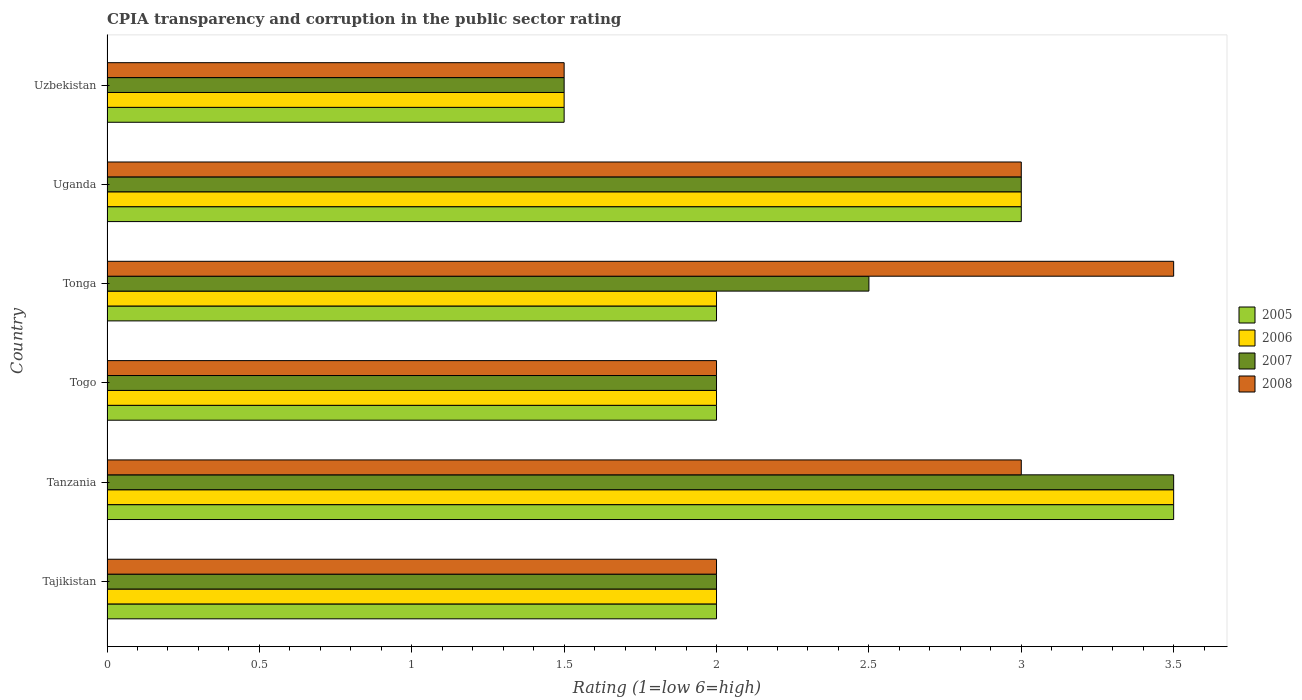How many groups of bars are there?
Make the answer very short. 6. Are the number of bars on each tick of the Y-axis equal?
Give a very brief answer. Yes. What is the label of the 5th group of bars from the top?
Make the answer very short. Tanzania. In how many cases, is the number of bars for a given country not equal to the number of legend labels?
Offer a terse response. 0. What is the CPIA rating in 2007 in Uzbekistan?
Give a very brief answer. 1.5. Across all countries, what is the minimum CPIA rating in 2006?
Provide a short and direct response. 1.5. In which country was the CPIA rating in 2008 maximum?
Offer a terse response. Tonga. In which country was the CPIA rating in 2005 minimum?
Provide a succinct answer. Uzbekistan. What is the average CPIA rating in 2006 per country?
Your answer should be very brief. 2.33. In how many countries, is the CPIA rating in 2005 greater than 0.8 ?
Offer a terse response. 6. What is the ratio of the CPIA rating in 2006 in Tanzania to that in Uzbekistan?
Make the answer very short. 2.33. Is the difference between the CPIA rating in 2006 in Tanzania and Uzbekistan greater than the difference between the CPIA rating in 2008 in Tanzania and Uzbekistan?
Your answer should be very brief. Yes. What is the difference between the highest and the second highest CPIA rating in 2007?
Your response must be concise. 0.5. In how many countries, is the CPIA rating in 2007 greater than the average CPIA rating in 2007 taken over all countries?
Ensure brevity in your answer.  3. Is the sum of the CPIA rating in 2008 in Tajikistan and Tanzania greater than the maximum CPIA rating in 2007 across all countries?
Offer a terse response. Yes. Is it the case that in every country, the sum of the CPIA rating in 2006 and CPIA rating in 2007 is greater than the sum of CPIA rating in 2008 and CPIA rating in 2005?
Provide a succinct answer. No. What does the 1st bar from the bottom in Tanzania represents?
Offer a very short reply. 2005. Are all the bars in the graph horizontal?
Offer a very short reply. Yes. What is the difference between two consecutive major ticks on the X-axis?
Your answer should be compact. 0.5. Are the values on the major ticks of X-axis written in scientific E-notation?
Provide a short and direct response. No. How many legend labels are there?
Keep it short and to the point. 4. How are the legend labels stacked?
Your answer should be very brief. Vertical. What is the title of the graph?
Provide a succinct answer. CPIA transparency and corruption in the public sector rating. Does "1989" appear as one of the legend labels in the graph?
Keep it short and to the point. No. What is the label or title of the X-axis?
Ensure brevity in your answer.  Rating (1=low 6=high). What is the Rating (1=low 6=high) of 2005 in Tajikistan?
Offer a very short reply. 2. What is the Rating (1=low 6=high) of 2005 in Tanzania?
Your response must be concise. 3.5. What is the Rating (1=low 6=high) in 2006 in Tanzania?
Your answer should be very brief. 3.5. What is the Rating (1=low 6=high) in 2007 in Tanzania?
Make the answer very short. 3.5. What is the Rating (1=low 6=high) in 2008 in Tanzania?
Make the answer very short. 3. What is the Rating (1=low 6=high) of 2005 in Togo?
Offer a very short reply. 2. What is the Rating (1=low 6=high) of 2007 in Togo?
Give a very brief answer. 2. What is the Rating (1=low 6=high) of 2005 in Tonga?
Offer a very short reply. 2. What is the Rating (1=low 6=high) of 2007 in Tonga?
Make the answer very short. 2.5. What is the Rating (1=low 6=high) in 2007 in Uzbekistan?
Give a very brief answer. 1.5. What is the Rating (1=low 6=high) of 2008 in Uzbekistan?
Ensure brevity in your answer.  1.5. Across all countries, what is the maximum Rating (1=low 6=high) in 2006?
Your answer should be very brief. 3.5. Across all countries, what is the maximum Rating (1=low 6=high) of 2007?
Your response must be concise. 3.5. Across all countries, what is the maximum Rating (1=low 6=high) in 2008?
Keep it short and to the point. 3.5. What is the total Rating (1=low 6=high) in 2006 in the graph?
Provide a short and direct response. 14. What is the total Rating (1=low 6=high) of 2007 in the graph?
Provide a succinct answer. 14.5. What is the difference between the Rating (1=low 6=high) of 2005 in Tajikistan and that in Tanzania?
Ensure brevity in your answer.  -1.5. What is the difference between the Rating (1=low 6=high) of 2007 in Tajikistan and that in Tanzania?
Make the answer very short. -1.5. What is the difference between the Rating (1=low 6=high) of 2005 in Tajikistan and that in Togo?
Provide a succinct answer. 0. What is the difference between the Rating (1=low 6=high) of 2006 in Tajikistan and that in Togo?
Offer a terse response. 0. What is the difference between the Rating (1=low 6=high) of 2005 in Tajikistan and that in Tonga?
Your answer should be very brief. 0. What is the difference between the Rating (1=low 6=high) of 2007 in Tajikistan and that in Tonga?
Offer a terse response. -0.5. What is the difference between the Rating (1=low 6=high) of 2008 in Tajikistan and that in Tonga?
Provide a short and direct response. -1.5. What is the difference between the Rating (1=low 6=high) in 2006 in Tajikistan and that in Uganda?
Your answer should be very brief. -1. What is the difference between the Rating (1=low 6=high) in 2005 in Tajikistan and that in Uzbekistan?
Provide a short and direct response. 0.5. What is the difference between the Rating (1=low 6=high) in 2006 in Tajikistan and that in Uzbekistan?
Ensure brevity in your answer.  0.5. What is the difference between the Rating (1=low 6=high) in 2005 in Tanzania and that in Togo?
Offer a terse response. 1.5. What is the difference between the Rating (1=low 6=high) of 2006 in Tanzania and that in Togo?
Your response must be concise. 1.5. What is the difference between the Rating (1=low 6=high) of 2007 in Tanzania and that in Togo?
Offer a very short reply. 1.5. What is the difference between the Rating (1=low 6=high) in 2005 in Tanzania and that in Tonga?
Give a very brief answer. 1.5. What is the difference between the Rating (1=low 6=high) in 2006 in Tanzania and that in Tonga?
Offer a terse response. 1.5. What is the difference between the Rating (1=low 6=high) of 2006 in Tanzania and that in Uganda?
Keep it short and to the point. 0.5. What is the difference between the Rating (1=low 6=high) in 2008 in Tanzania and that in Uganda?
Provide a succinct answer. 0. What is the difference between the Rating (1=low 6=high) in 2005 in Tanzania and that in Uzbekistan?
Provide a succinct answer. 2. What is the difference between the Rating (1=low 6=high) in 2008 in Tanzania and that in Uzbekistan?
Offer a very short reply. 1.5. What is the difference between the Rating (1=low 6=high) in 2006 in Togo and that in Tonga?
Provide a succinct answer. 0. What is the difference between the Rating (1=low 6=high) of 2007 in Togo and that in Tonga?
Your answer should be compact. -0.5. What is the difference between the Rating (1=low 6=high) in 2008 in Togo and that in Tonga?
Provide a succinct answer. -1.5. What is the difference between the Rating (1=low 6=high) of 2005 in Togo and that in Uganda?
Provide a succinct answer. -1. What is the difference between the Rating (1=low 6=high) of 2008 in Togo and that in Uganda?
Your response must be concise. -1. What is the difference between the Rating (1=low 6=high) in 2005 in Togo and that in Uzbekistan?
Provide a short and direct response. 0.5. What is the difference between the Rating (1=low 6=high) of 2008 in Togo and that in Uzbekistan?
Offer a terse response. 0.5. What is the difference between the Rating (1=low 6=high) in 2006 in Tonga and that in Uganda?
Your response must be concise. -1. What is the difference between the Rating (1=low 6=high) in 2008 in Tonga and that in Uganda?
Provide a short and direct response. 0.5. What is the difference between the Rating (1=low 6=high) of 2005 in Uganda and that in Uzbekistan?
Your response must be concise. 1.5. What is the difference between the Rating (1=low 6=high) of 2007 in Uganda and that in Uzbekistan?
Your answer should be compact. 1.5. What is the difference between the Rating (1=low 6=high) of 2008 in Uganda and that in Uzbekistan?
Ensure brevity in your answer.  1.5. What is the difference between the Rating (1=low 6=high) in 2005 in Tajikistan and the Rating (1=low 6=high) in 2008 in Tanzania?
Make the answer very short. -1. What is the difference between the Rating (1=low 6=high) of 2006 in Tajikistan and the Rating (1=low 6=high) of 2007 in Togo?
Give a very brief answer. 0. What is the difference between the Rating (1=low 6=high) in 2005 in Tajikistan and the Rating (1=low 6=high) in 2006 in Tonga?
Provide a succinct answer. 0. What is the difference between the Rating (1=low 6=high) of 2005 in Tajikistan and the Rating (1=low 6=high) of 2008 in Tonga?
Provide a succinct answer. -1.5. What is the difference between the Rating (1=low 6=high) of 2005 in Tajikistan and the Rating (1=low 6=high) of 2007 in Uganda?
Your answer should be compact. -1. What is the difference between the Rating (1=low 6=high) in 2006 in Tajikistan and the Rating (1=low 6=high) in 2007 in Uganda?
Your response must be concise. -1. What is the difference between the Rating (1=low 6=high) in 2005 in Tajikistan and the Rating (1=low 6=high) in 2006 in Uzbekistan?
Your answer should be compact. 0.5. What is the difference between the Rating (1=low 6=high) in 2005 in Tajikistan and the Rating (1=low 6=high) in 2007 in Uzbekistan?
Give a very brief answer. 0.5. What is the difference between the Rating (1=low 6=high) of 2006 in Tajikistan and the Rating (1=low 6=high) of 2007 in Uzbekistan?
Your answer should be compact. 0.5. What is the difference between the Rating (1=low 6=high) in 2006 in Tajikistan and the Rating (1=low 6=high) in 2008 in Uzbekistan?
Give a very brief answer. 0.5. What is the difference between the Rating (1=low 6=high) of 2007 in Tajikistan and the Rating (1=low 6=high) of 2008 in Uzbekistan?
Make the answer very short. 0.5. What is the difference between the Rating (1=low 6=high) in 2005 in Tanzania and the Rating (1=low 6=high) in 2006 in Togo?
Make the answer very short. 1.5. What is the difference between the Rating (1=low 6=high) of 2005 in Tanzania and the Rating (1=low 6=high) of 2008 in Togo?
Your response must be concise. 1.5. What is the difference between the Rating (1=low 6=high) in 2006 in Tanzania and the Rating (1=low 6=high) in 2007 in Togo?
Provide a succinct answer. 1.5. What is the difference between the Rating (1=low 6=high) of 2007 in Tanzania and the Rating (1=low 6=high) of 2008 in Togo?
Offer a very short reply. 1.5. What is the difference between the Rating (1=low 6=high) in 2005 in Tanzania and the Rating (1=low 6=high) in 2006 in Tonga?
Provide a short and direct response. 1.5. What is the difference between the Rating (1=low 6=high) in 2005 in Tanzania and the Rating (1=low 6=high) in 2007 in Tonga?
Provide a succinct answer. 1. What is the difference between the Rating (1=low 6=high) of 2006 in Tanzania and the Rating (1=low 6=high) of 2007 in Tonga?
Your response must be concise. 1. What is the difference between the Rating (1=low 6=high) of 2006 in Tanzania and the Rating (1=low 6=high) of 2008 in Tonga?
Keep it short and to the point. 0. What is the difference between the Rating (1=low 6=high) of 2007 in Tanzania and the Rating (1=low 6=high) of 2008 in Tonga?
Your response must be concise. 0. What is the difference between the Rating (1=low 6=high) in 2005 in Tanzania and the Rating (1=low 6=high) in 2006 in Uganda?
Provide a short and direct response. 0.5. What is the difference between the Rating (1=low 6=high) in 2006 in Tanzania and the Rating (1=low 6=high) in 2007 in Uganda?
Provide a short and direct response. 0.5. What is the difference between the Rating (1=low 6=high) in 2006 in Tanzania and the Rating (1=low 6=high) in 2008 in Uganda?
Ensure brevity in your answer.  0.5. What is the difference between the Rating (1=low 6=high) of 2007 in Tanzania and the Rating (1=low 6=high) of 2008 in Uganda?
Give a very brief answer. 0.5. What is the difference between the Rating (1=low 6=high) in 2005 in Tanzania and the Rating (1=low 6=high) in 2008 in Uzbekistan?
Make the answer very short. 2. What is the difference between the Rating (1=low 6=high) of 2006 in Tanzania and the Rating (1=low 6=high) of 2007 in Uzbekistan?
Give a very brief answer. 2. What is the difference between the Rating (1=low 6=high) in 2007 in Tanzania and the Rating (1=low 6=high) in 2008 in Uzbekistan?
Make the answer very short. 2. What is the difference between the Rating (1=low 6=high) of 2005 in Togo and the Rating (1=low 6=high) of 2006 in Tonga?
Your response must be concise. 0. What is the difference between the Rating (1=low 6=high) in 2005 in Togo and the Rating (1=low 6=high) in 2007 in Tonga?
Keep it short and to the point. -0.5. What is the difference between the Rating (1=low 6=high) in 2006 in Togo and the Rating (1=low 6=high) in 2007 in Tonga?
Make the answer very short. -0.5. What is the difference between the Rating (1=low 6=high) in 2006 in Togo and the Rating (1=low 6=high) in 2008 in Tonga?
Your answer should be very brief. -1.5. What is the difference between the Rating (1=low 6=high) in 2007 in Togo and the Rating (1=low 6=high) in 2008 in Tonga?
Offer a terse response. -1.5. What is the difference between the Rating (1=low 6=high) of 2005 in Togo and the Rating (1=low 6=high) of 2006 in Uganda?
Keep it short and to the point. -1. What is the difference between the Rating (1=low 6=high) in 2005 in Togo and the Rating (1=low 6=high) in 2007 in Uganda?
Your answer should be compact. -1. What is the difference between the Rating (1=low 6=high) in 2006 in Togo and the Rating (1=low 6=high) in 2007 in Uganda?
Keep it short and to the point. -1. What is the difference between the Rating (1=low 6=high) in 2006 in Togo and the Rating (1=low 6=high) in 2008 in Uganda?
Offer a very short reply. -1. What is the difference between the Rating (1=low 6=high) of 2005 in Togo and the Rating (1=low 6=high) of 2006 in Uzbekistan?
Offer a very short reply. 0.5. What is the difference between the Rating (1=low 6=high) of 2006 in Togo and the Rating (1=low 6=high) of 2008 in Uzbekistan?
Offer a terse response. 0.5. What is the difference between the Rating (1=low 6=high) in 2005 in Tonga and the Rating (1=low 6=high) in 2006 in Uganda?
Make the answer very short. -1. What is the difference between the Rating (1=low 6=high) in 2005 in Tonga and the Rating (1=low 6=high) in 2007 in Uganda?
Provide a short and direct response. -1. What is the difference between the Rating (1=low 6=high) in 2007 in Tonga and the Rating (1=low 6=high) in 2008 in Uganda?
Your response must be concise. -0.5. What is the difference between the Rating (1=low 6=high) in 2006 in Tonga and the Rating (1=low 6=high) in 2007 in Uzbekistan?
Offer a terse response. 0.5. What is the difference between the Rating (1=low 6=high) of 2006 in Tonga and the Rating (1=low 6=high) of 2008 in Uzbekistan?
Give a very brief answer. 0.5. What is the difference between the Rating (1=low 6=high) of 2005 in Uganda and the Rating (1=low 6=high) of 2007 in Uzbekistan?
Provide a succinct answer. 1.5. What is the average Rating (1=low 6=high) of 2005 per country?
Provide a short and direct response. 2.33. What is the average Rating (1=low 6=high) in 2006 per country?
Make the answer very short. 2.33. What is the average Rating (1=low 6=high) in 2007 per country?
Your answer should be very brief. 2.42. What is the difference between the Rating (1=low 6=high) in 2005 and Rating (1=low 6=high) in 2006 in Tajikistan?
Offer a terse response. 0. What is the difference between the Rating (1=low 6=high) of 2005 and Rating (1=low 6=high) of 2008 in Tajikistan?
Provide a short and direct response. 0. What is the difference between the Rating (1=low 6=high) of 2006 and Rating (1=low 6=high) of 2007 in Tajikistan?
Offer a terse response. 0. What is the difference between the Rating (1=low 6=high) of 2007 and Rating (1=low 6=high) of 2008 in Tajikistan?
Make the answer very short. 0. What is the difference between the Rating (1=low 6=high) in 2005 and Rating (1=low 6=high) in 2007 in Tanzania?
Offer a very short reply. 0. What is the difference between the Rating (1=low 6=high) of 2005 and Rating (1=low 6=high) of 2008 in Tanzania?
Your response must be concise. 0.5. What is the difference between the Rating (1=low 6=high) of 2006 and Rating (1=low 6=high) of 2007 in Tanzania?
Make the answer very short. 0. What is the difference between the Rating (1=low 6=high) in 2006 and Rating (1=low 6=high) in 2008 in Tanzania?
Keep it short and to the point. 0.5. What is the difference between the Rating (1=low 6=high) in 2005 and Rating (1=low 6=high) in 2007 in Togo?
Offer a very short reply. 0. What is the difference between the Rating (1=low 6=high) in 2006 and Rating (1=low 6=high) in 2007 in Togo?
Your response must be concise. 0. What is the difference between the Rating (1=low 6=high) of 2005 and Rating (1=low 6=high) of 2006 in Tonga?
Your response must be concise. 0. What is the difference between the Rating (1=low 6=high) of 2006 and Rating (1=low 6=high) of 2007 in Tonga?
Ensure brevity in your answer.  -0.5. What is the difference between the Rating (1=low 6=high) of 2007 and Rating (1=low 6=high) of 2008 in Tonga?
Provide a short and direct response. -1. What is the difference between the Rating (1=low 6=high) of 2005 and Rating (1=low 6=high) of 2007 in Uganda?
Make the answer very short. 0. What is the difference between the Rating (1=low 6=high) of 2005 and Rating (1=low 6=high) of 2008 in Uganda?
Provide a short and direct response. 0. What is the difference between the Rating (1=low 6=high) in 2006 and Rating (1=low 6=high) in 2007 in Uganda?
Provide a short and direct response. 0. What is the difference between the Rating (1=low 6=high) in 2006 and Rating (1=low 6=high) in 2008 in Uganda?
Offer a terse response. 0. What is the difference between the Rating (1=low 6=high) in 2007 and Rating (1=low 6=high) in 2008 in Uganda?
Offer a very short reply. 0. What is the difference between the Rating (1=low 6=high) in 2005 and Rating (1=low 6=high) in 2008 in Uzbekistan?
Offer a very short reply. 0. What is the difference between the Rating (1=low 6=high) in 2006 and Rating (1=low 6=high) in 2007 in Uzbekistan?
Your answer should be compact. 0. What is the difference between the Rating (1=low 6=high) in 2006 and Rating (1=low 6=high) in 2008 in Uzbekistan?
Offer a terse response. 0. What is the difference between the Rating (1=low 6=high) of 2007 and Rating (1=low 6=high) of 2008 in Uzbekistan?
Make the answer very short. 0. What is the ratio of the Rating (1=low 6=high) in 2005 in Tajikistan to that in Tanzania?
Keep it short and to the point. 0.57. What is the ratio of the Rating (1=low 6=high) of 2006 in Tajikistan to that in Tanzania?
Your answer should be very brief. 0.57. What is the ratio of the Rating (1=low 6=high) in 2008 in Tajikistan to that in Tanzania?
Keep it short and to the point. 0.67. What is the ratio of the Rating (1=low 6=high) of 2006 in Tajikistan to that in Togo?
Offer a very short reply. 1. What is the ratio of the Rating (1=low 6=high) of 2007 in Tajikistan to that in Tonga?
Keep it short and to the point. 0.8. What is the ratio of the Rating (1=low 6=high) of 2008 in Tajikistan to that in Tonga?
Your answer should be very brief. 0.57. What is the ratio of the Rating (1=low 6=high) of 2006 in Tajikistan to that in Uganda?
Offer a terse response. 0.67. What is the ratio of the Rating (1=low 6=high) in 2008 in Tajikistan to that in Uganda?
Your response must be concise. 0.67. What is the ratio of the Rating (1=low 6=high) in 2006 in Tanzania to that in Togo?
Offer a terse response. 1.75. What is the ratio of the Rating (1=low 6=high) of 2007 in Tanzania to that in Togo?
Give a very brief answer. 1.75. What is the ratio of the Rating (1=low 6=high) of 2005 in Tanzania to that in Tonga?
Keep it short and to the point. 1.75. What is the ratio of the Rating (1=low 6=high) of 2008 in Tanzania to that in Uganda?
Make the answer very short. 1. What is the ratio of the Rating (1=low 6=high) of 2005 in Tanzania to that in Uzbekistan?
Provide a short and direct response. 2.33. What is the ratio of the Rating (1=low 6=high) in 2006 in Tanzania to that in Uzbekistan?
Provide a succinct answer. 2.33. What is the ratio of the Rating (1=low 6=high) in 2007 in Tanzania to that in Uzbekistan?
Your answer should be compact. 2.33. What is the ratio of the Rating (1=low 6=high) of 2008 in Tanzania to that in Uzbekistan?
Ensure brevity in your answer.  2. What is the ratio of the Rating (1=low 6=high) of 2005 in Togo to that in Tonga?
Make the answer very short. 1. What is the ratio of the Rating (1=low 6=high) in 2006 in Togo to that in Tonga?
Your answer should be very brief. 1. What is the ratio of the Rating (1=low 6=high) of 2007 in Togo to that in Tonga?
Your answer should be compact. 0.8. What is the ratio of the Rating (1=low 6=high) in 2008 in Togo to that in Tonga?
Provide a short and direct response. 0.57. What is the ratio of the Rating (1=low 6=high) of 2005 in Togo to that in Uganda?
Give a very brief answer. 0.67. What is the ratio of the Rating (1=low 6=high) of 2006 in Togo to that in Uganda?
Your answer should be compact. 0.67. What is the ratio of the Rating (1=low 6=high) in 2007 in Togo to that in Uganda?
Ensure brevity in your answer.  0.67. What is the ratio of the Rating (1=low 6=high) in 2005 in Togo to that in Uzbekistan?
Make the answer very short. 1.33. What is the ratio of the Rating (1=low 6=high) of 2006 in Togo to that in Uzbekistan?
Provide a succinct answer. 1.33. What is the ratio of the Rating (1=low 6=high) of 2007 in Togo to that in Uzbekistan?
Ensure brevity in your answer.  1.33. What is the ratio of the Rating (1=low 6=high) of 2005 in Tonga to that in Uganda?
Offer a terse response. 0.67. What is the ratio of the Rating (1=low 6=high) in 2006 in Tonga to that in Uganda?
Make the answer very short. 0.67. What is the ratio of the Rating (1=low 6=high) of 2005 in Tonga to that in Uzbekistan?
Your response must be concise. 1.33. What is the ratio of the Rating (1=low 6=high) of 2008 in Tonga to that in Uzbekistan?
Offer a terse response. 2.33. What is the ratio of the Rating (1=low 6=high) in 2005 in Uganda to that in Uzbekistan?
Your answer should be very brief. 2. What is the ratio of the Rating (1=low 6=high) in 2006 in Uganda to that in Uzbekistan?
Provide a succinct answer. 2. What is the ratio of the Rating (1=low 6=high) of 2008 in Uganda to that in Uzbekistan?
Your response must be concise. 2. What is the difference between the highest and the second highest Rating (1=low 6=high) of 2005?
Your response must be concise. 0.5. What is the difference between the highest and the second highest Rating (1=low 6=high) of 2007?
Your answer should be very brief. 0.5. What is the difference between the highest and the second highest Rating (1=low 6=high) of 2008?
Offer a very short reply. 0.5. What is the difference between the highest and the lowest Rating (1=low 6=high) in 2007?
Offer a very short reply. 2. What is the difference between the highest and the lowest Rating (1=low 6=high) of 2008?
Your response must be concise. 2. 